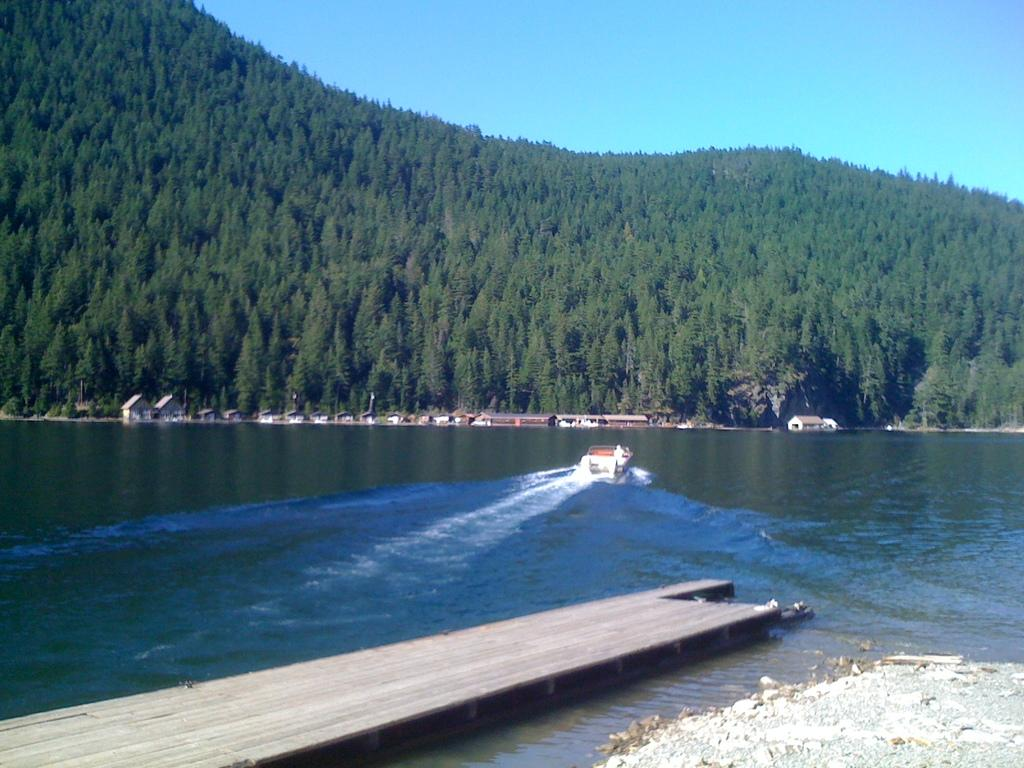What is the main structure in the image? There is a platform in the image. What is located on the water near the platform? There is a boat on water in the image. What can be seen in the background of the image? There are sheds and trees in the background of the image. What part of the natural environment is visible in the image? The sky is visible in the background of the image. What type of haircut is the laborer receiving in the image? There is no laborer or haircut present in the image. What error can be seen in the image? There is no error present in the image; it appears to be a clear and accurate representation of the scene. 